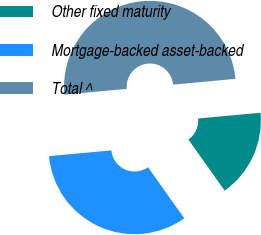Convert chart to OTSL. <chart><loc_0><loc_0><loc_500><loc_500><pie_chart><fcel>Other fixed maturity<fcel>Mortgage-backed asset-backed<fcel>Total ^<nl><fcel>16.63%<fcel>33.37%<fcel>50.0%<nl></chart> 